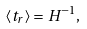Convert formula to latex. <formula><loc_0><loc_0><loc_500><loc_500>\langle t _ { r } \rangle = H ^ { - 1 } ,</formula> 